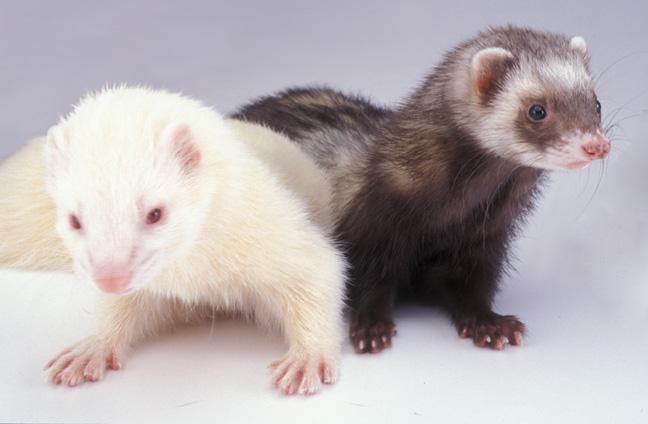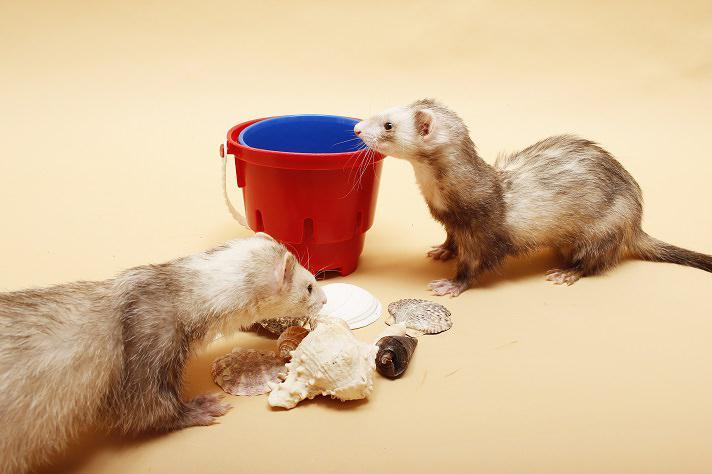The first image is the image on the left, the second image is the image on the right. Examine the images to the left and right. Is the description "An image contains exactly two ferrets, and one has its head over the other ferret's neck area." accurate? Answer yes or no. No. The first image is the image on the left, the second image is the image on the right. For the images shown, is this caption "The right image contains exactly two ferrets." true? Answer yes or no. Yes. 